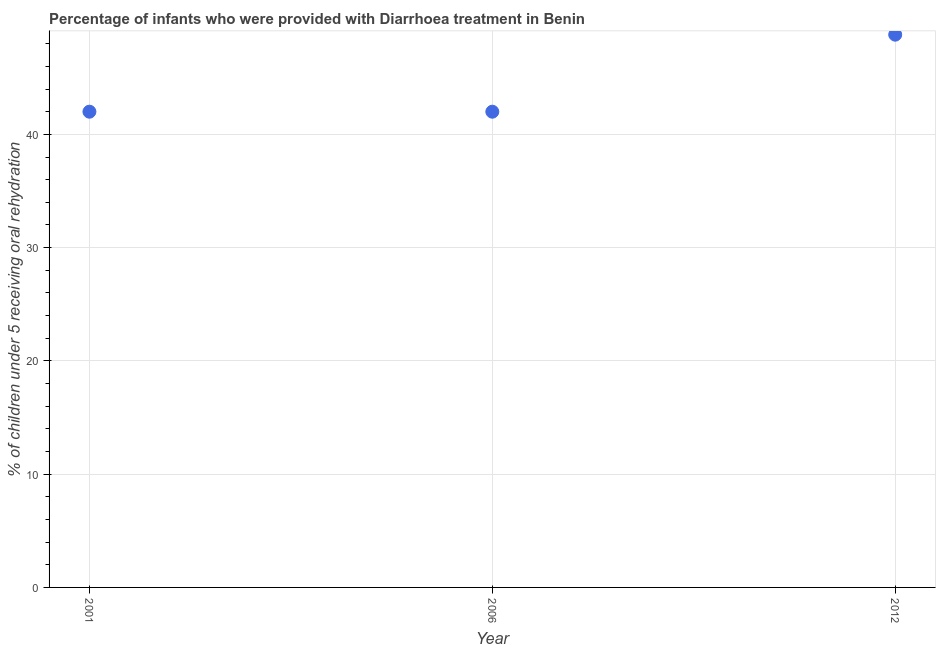Across all years, what is the maximum percentage of children who were provided with treatment diarrhoea?
Your answer should be very brief. 48.8. In which year was the percentage of children who were provided with treatment diarrhoea maximum?
Give a very brief answer. 2012. In which year was the percentage of children who were provided with treatment diarrhoea minimum?
Make the answer very short. 2001. What is the sum of the percentage of children who were provided with treatment diarrhoea?
Provide a short and direct response. 132.8. What is the difference between the percentage of children who were provided with treatment diarrhoea in 2001 and 2006?
Your answer should be very brief. 0. What is the average percentage of children who were provided with treatment diarrhoea per year?
Provide a short and direct response. 44.27. What is the median percentage of children who were provided with treatment diarrhoea?
Your answer should be very brief. 42. In how many years, is the percentage of children who were provided with treatment diarrhoea greater than 2 %?
Your response must be concise. 3. What is the ratio of the percentage of children who were provided with treatment diarrhoea in 2001 to that in 2006?
Keep it short and to the point. 1. What is the difference between the highest and the second highest percentage of children who were provided with treatment diarrhoea?
Provide a succinct answer. 6.8. Is the sum of the percentage of children who were provided with treatment diarrhoea in 2006 and 2012 greater than the maximum percentage of children who were provided with treatment diarrhoea across all years?
Give a very brief answer. Yes. What is the difference between the highest and the lowest percentage of children who were provided with treatment diarrhoea?
Your response must be concise. 6.8. In how many years, is the percentage of children who were provided with treatment diarrhoea greater than the average percentage of children who were provided with treatment diarrhoea taken over all years?
Provide a succinct answer. 1. How many years are there in the graph?
Ensure brevity in your answer.  3. What is the difference between two consecutive major ticks on the Y-axis?
Provide a short and direct response. 10. Are the values on the major ticks of Y-axis written in scientific E-notation?
Your response must be concise. No. Does the graph contain any zero values?
Keep it short and to the point. No. Does the graph contain grids?
Give a very brief answer. Yes. What is the title of the graph?
Make the answer very short. Percentage of infants who were provided with Diarrhoea treatment in Benin. What is the label or title of the Y-axis?
Your answer should be compact. % of children under 5 receiving oral rehydration. What is the % of children under 5 receiving oral rehydration in 2001?
Give a very brief answer. 42. What is the % of children under 5 receiving oral rehydration in 2006?
Offer a terse response. 42. What is the % of children under 5 receiving oral rehydration in 2012?
Provide a succinct answer. 48.8. What is the difference between the % of children under 5 receiving oral rehydration in 2001 and 2012?
Your answer should be compact. -6.8. What is the difference between the % of children under 5 receiving oral rehydration in 2006 and 2012?
Provide a succinct answer. -6.8. What is the ratio of the % of children under 5 receiving oral rehydration in 2001 to that in 2006?
Your answer should be very brief. 1. What is the ratio of the % of children under 5 receiving oral rehydration in 2001 to that in 2012?
Make the answer very short. 0.86. What is the ratio of the % of children under 5 receiving oral rehydration in 2006 to that in 2012?
Give a very brief answer. 0.86. 